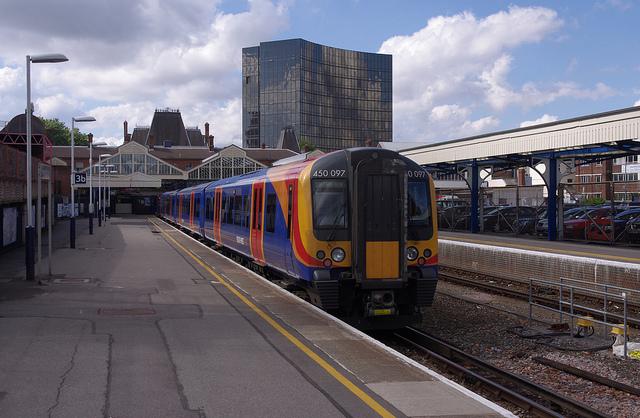What number is on the tram?
Quick response, please. 450 097. Is the train moving?
Short answer required. No. Are there people waiting for the train?
Short answer required. No. Are there clouds reflecting on the building in the background?
Give a very brief answer. Yes. Is there more than one track visible?
Write a very short answer. Yes. What colors are the train?
Short answer required. Red, blue and yellow. What is above the train?
Short answer required. Building. How many clouds are in the picture?
Keep it brief. Many. Is it a sunny day outside?
Concise answer only. Yes. Is the train ' s headlights on?
Give a very brief answer. No. 